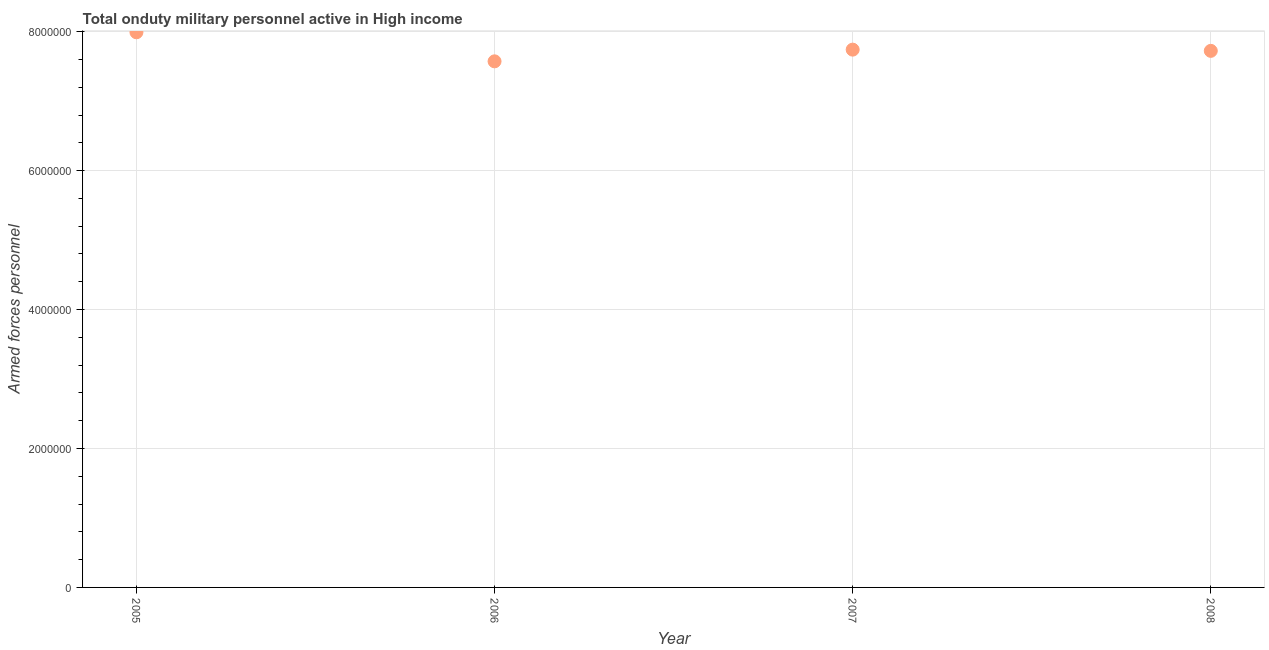What is the number of armed forces personnel in 2007?
Provide a short and direct response. 7.74e+06. Across all years, what is the maximum number of armed forces personnel?
Keep it short and to the point. 7.99e+06. Across all years, what is the minimum number of armed forces personnel?
Offer a terse response. 7.57e+06. What is the sum of the number of armed forces personnel?
Make the answer very short. 3.10e+07. What is the difference between the number of armed forces personnel in 2005 and 2006?
Ensure brevity in your answer.  4.18e+05. What is the average number of armed forces personnel per year?
Offer a terse response. 7.76e+06. What is the median number of armed forces personnel?
Your answer should be very brief. 7.73e+06. Do a majority of the years between 2005 and 2008 (inclusive) have number of armed forces personnel greater than 2400000 ?
Ensure brevity in your answer.  Yes. What is the ratio of the number of armed forces personnel in 2006 to that in 2007?
Make the answer very short. 0.98. Is the number of armed forces personnel in 2006 less than that in 2008?
Your answer should be compact. Yes. Is the difference between the number of armed forces personnel in 2006 and 2007 greater than the difference between any two years?
Provide a succinct answer. No. What is the difference between the highest and the second highest number of armed forces personnel?
Your answer should be very brief. 2.50e+05. Is the sum of the number of armed forces personnel in 2007 and 2008 greater than the maximum number of armed forces personnel across all years?
Offer a very short reply. Yes. What is the difference between the highest and the lowest number of armed forces personnel?
Keep it short and to the point. 4.18e+05. In how many years, is the number of armed forces personnel greater than the average number of armed forces personnel taken over all years?
Your answer should be compact. 1. How many years are there in the graph?
Ensure brevity in your answer.  4. What is the difference between two consecutive major ticks on the Y-axis?
Offer a very short reply. 2.00e+06. Are the values on the major ticks of Y-axis written in scientific E-notation?
Your response must be concise. No. Does the graph contain any zero values?
Provide a short and direct response. No. Does the graph contain grids?
Ensure brevity in your answer.  Yes. What is the title of the graph?
Provide a succinct answer. Total onduty military personnel active in High income. What is the label or title of the X-axis?
Make the answer very short. Year. What is the label or title of the Y-axis?
Your response must be concise. Armed forces personnel. What is the Armed forces personnel in 2005?
Keep it short and to the point. 7.99e+06. What is the Armed forces personnel in 2006?
Your answer should be very brief. 7.57e+06. What is the Armed forces personnel in 2007?
Your response must be concise. 7.74e+06. What is the Armed forces personnel in 2008?
Your answer should be very brief. 7.72e+06. What is the difference between the Armed forces personnel in 2005 and 2006?
Ensure brevity in your answer.  4.18e+05. What is the difference between the Armed forces personnel in 2005 and 2007?
Your response must be concise. 2.50e+05. What is the difference between the Armed forces personnel in 2005 and 2008?
Give a very brief answer. 2.67e+05. What is the difference between the Armed forces personnel in 2006 and 2007?
Provide a short and direct response. -1.68e+05. What is the difference between the Armed forces personnel in 2006 and 2008?
Make the answer very short. -1.51e+05. What is the difference between the Armed forces personnel in 2007 and 2008?
Offer a terse response. 1.75e+04. What is the ratio of the Armed forces personnel in 2005 to that in 2006?
Provide a short and direct response. 1.05. What is the ratio of the Armed forces personnel in 2005 to that in 2007?
Your answer should be compact. 1.03. What is the ratio of the Armed forces personnel in 2005 to that in 2008?
Offer a very short reply. 1.03. What is the ratio of the Armed forces personnel in 2006 to that in 2007?
Offer a terse response. 0.98. What is the ratio of the Armed forces personnel in 2007 to that in 2008?
Your response must be concise. 1. 